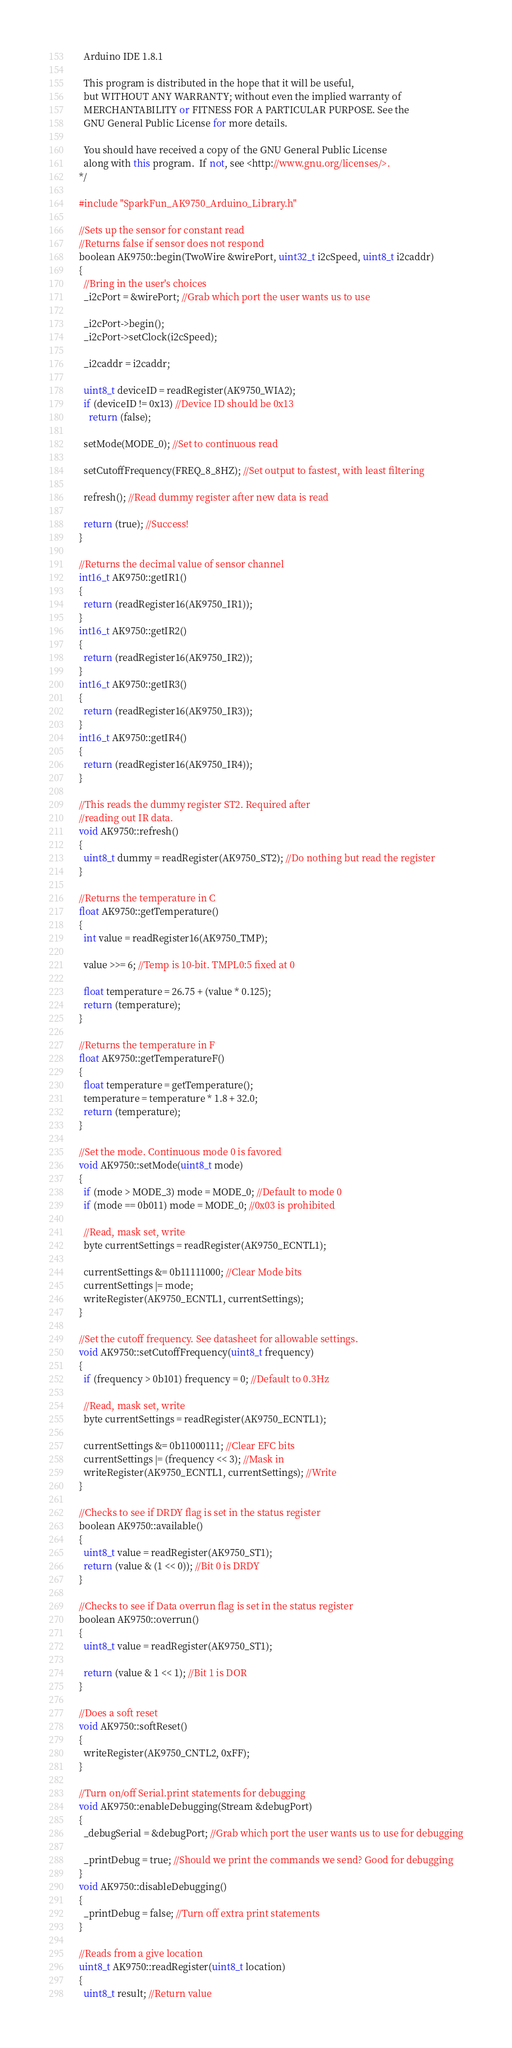Convert code to text. <code><loc_0><loc_0><loc_500><loc_500><_C++_>  Arduino IDE 1.8.1

  This program is distributed in the hope that it will be useful,
  but WITHOUT ANY WARRANTY; without even the implied warranty of
  MERCHANTABILITY or FITNESS FOR A PARTICULAR PURPOSE. See the
  GNU General Public License for more details.

  You should have received a copy of the GNU General Public License
  along with this program.  If not, see <http://www.gnu.org/licenses/>.
*/

#include "SparkFun_AK9750_Arduino_Library.h"

//Sets up the sensor for constant read
//Returns false if sensor does not respond
boolean AK9750::begin(TwoWire &wirePort, uint32_t i2cSpeed, uint8_t i2caddr)
{
  //Bring in the user's choices
  _i2cPort = &wirePort; //Grab which port the user wants us to use

  _i2cPort->begin();
  _i2cPort->setClock(i2cSpeed);

  _i2caddr = i2caddr;

  uint8_t deviceID = readRegister(AK9750_WIA2);
  if (deviceID != 0x13) //Device ID should be 0x13
    return (false);

  setMode(MODE_0); //Set to continuous read

  setCutoffFrequency(FREQ_8_8HZ); //Set output to fastest, with least filtering

  refresh(); //Read dummy register after new data is read

  return (true); //Success!
}

//Returns the decimal value of sensor channel
int16_t AK9750::getIR1()
{
  return (readRegister16(AK9750_IR1));
}
int16_t AK9750::getIR2()
{
  return (readRegister16(AK9750_IR2));
}
int16_t AK9750::getIR3()
{
  return (readRegister16(AK9750_IR3));
}
int16_t AK9750::getIR4()
{
  return (readRegister16(AK9750_IR4));
}

//This reads the dummy register ST2. Required after
//reading out IR data.
void AK9750::refresh()
{
  uint8_t dummy = readRegister(AK9750_ST2); //Do nothing but read the register
}

//Returns the temperature in C
float AK9750::getTemperature()
{
  int value = readRegister16(AK9750_TMP);

  value >>= 6; //Temp is 10-bit. TMPL0:5 fixed at 0

  float temperature = 26.75 + (value * 0.125);
  return (temperature);
}

//Returns the temperature in F
float AK9750::getTemperatureF()
{
  float temperature = getTemperature();
  temperature = temperature * 1.8 + 32.0;
  return (temperature);
}

//Set the mode. Continuous mode 0 is favored
void AK9750::setMode(uint8_t mode)
{
  if (mode > MODE_3) mode = MODE_0; //Default to mode 0
  if (mode == 0b011) mode = MODE_0; //0x03 is prohibited

  //Read, mask set, write
  byte currentSettings = readRegister(AK9750_ECNTL1);

  currentSettings &= 0b11111000; //Clear Mode bits
  currentSettings |= mode;
  writeRegister(AK9750_ECNTL1, currentSettings);
}

//Set the cutoff frequency. See datasheet for allowable settings.
void AK9750::setCutoffFrequency(uint8_t frequency)
{
  if (frequency > 0b101) frequency = 0; //Default to 0.3Hz

  //Read, mask set, write
  byte currentSettings = readRegister(AK9750_ECNTL1);

  currentSettings &= 0b11000111; //Clear EFC bits
  currentSettings |= (frequency << 3); //Mask in
  writeRegister(AK9750_ECNTL1, currentSettings); //Write
}

//Checks to see if DRDY flag is set in the status register
boolean AK9750::available()
{
  uint8_t value = readRegister(AK9750_ST1);
  return (value & (1 << 0)); //Bit 0 is DRDY
}

//Checks to see if Data overrun flag is set in the status register
boolean AK9750::overrun()
{
  uint8_t value = readRegister(AK9750_ST1);

  return (value & 1 << 1); //Bit 1 is DOR
}

//Does a soft reset
void AK9750::softReset()
{
  writeRegister(AK9750_CNTL2, 0xFF);
}

//Turn on/off Serial.print statements for debugging
void AK9750::enableDebugging(Stream &debugPort)
{
  _debugSerial = &debugPort; //Grab which port the user wants us to use for debugging

  _printDebug = true; //Should we print the commands we send? Good for debugging
}
void AK9750::disableDebugging()
{
  _printDebug = false; //Turn off extra print statements
}

//Reads from a give location
uint8_t AK9750::readRegister(uint8_t location)
{
  uint8_t result; //Return value
</code> 